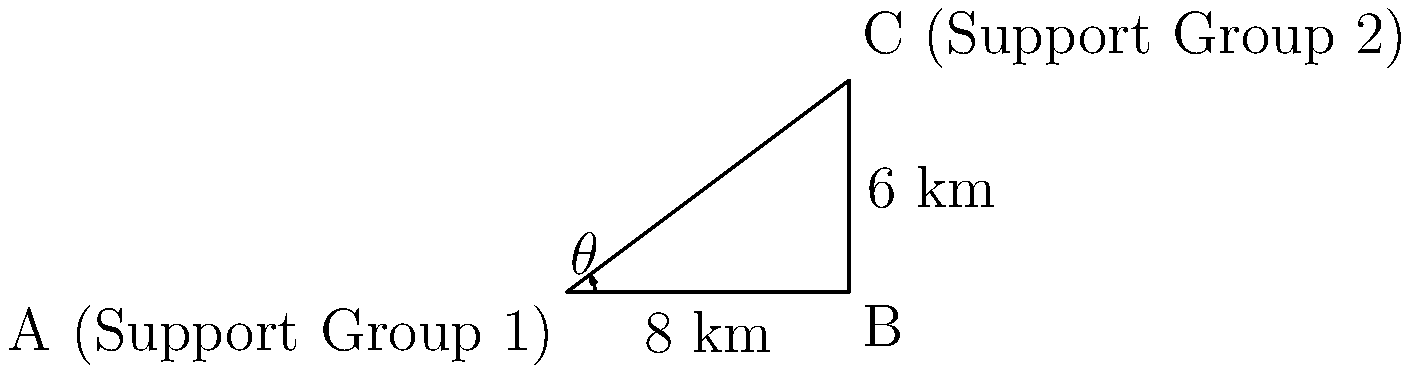Two transgender support group locations are situated in a city as shown in the diagram. Support Group 1 is at point A, and Support Group 2 is at point C. The distance from A to B is 8 km, and the distance from B to C is 6 km. The angle $\theta$ at point A is 36.87°. Calculate the direct distance between the two support group locations (AC) to the nearest 0.1 km. To solve this problem, we'll use the law of cosines, which is ideal for triangles where we know two sides and the included angle.

1) The law of cosines states: $c^2 = a^2 + b^2 - 2ab \cos(C)$

   Where:
   $c$ is the side we're trying to find (AC)
   $a$ and $b$ are the known sides (AB and BC)
   $C$ is the angle opposite to side $c$

2) In our case:
   $a = 8$ km (AB)
   $b = 10$ km (BC)
   $C = 180° - 90° - 36.87° = 53.13°$ (angle at B is 90°, as it forms a right triangle)

3) Let's substitute these values into the formula:

   $AC^2 = 8^2 + 10^2 - 2(8)(10) \cos(53.13°)$

4) Simplify:
   $AC^2 = 64 + 100 - 160 \cos(53.13°)$

5) Calculate:
   $AC^2 = 164 - 160(0.6)$
   $AC^2 = 164 - 96 = 68$

6) Take the square root of both sides:
   $AC = \sqrt{68} \approx 8.246$ km

7) Rounding to the nearest 0.1 km:
   $AC \approx 8.2$ km
Answer: 8.2 km 